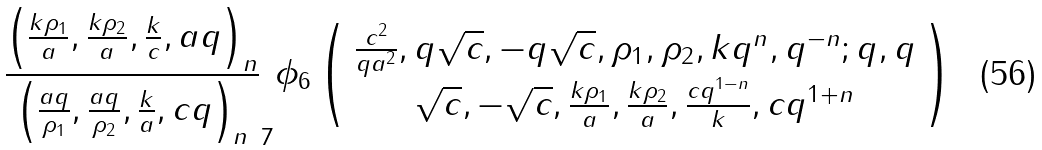<formula> <loc_0><loc_0><loc_500><loc_500>\frac { \left ( \frac { k \rho _ { 1 } } { a } , \frac { k \rho _ { 2 } } { a } , \frac { k } { c } , a q \right ) _ { n } } { \left ( \frac { a q } { \rho _ { 1 } } , \frac { a q } { \rho _ { 2 } } , \frac { k } { a } , c q \right ) _ { n } } _ { 7 } \phi _ { 6 } \left ( \begin{array} { c } \frac { c ^ { 2 } } { q a ^ { 2 } } , q \sqrt { c } , - q \sqrt { c } , \rho _ { 1 } , \rho _ { 2 } , k q ^ { n } , q ^ { - n } ; q , q \\ \sqrt { c } , - \sqrt { c } , \frac { k \rho _ { 1 } } { a } , \frac { k \rho _ { 2 } } { a } , \frac { c q ^ { 1 - n } } { k } , c q ^ { 1 + n } \end{array} \right )</formula> 